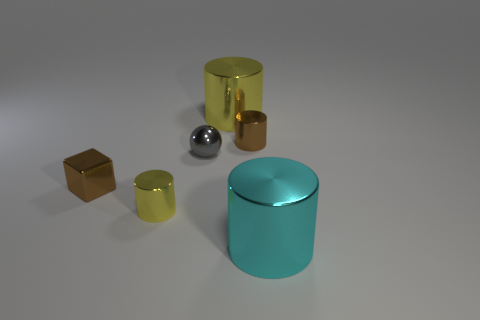Subtract all cyan cylinders. How many cylinders are left? 3 Subtract all red cylinders. Subtract all cyan cubes. How many cylinders are left? 4 Add 2 cyan cylinders. How many objects exist? 8 Subtract all cylinders. How many objects are left? 2 Subtract 0 cyan spheres. How many objects are left? 6 Subtract all small red metal things. Subtract all brown objects. How many objects are left? 4 Add 4 brown metal cylinders. How many brown metal cylinders are left? 5 Add 5 big red metal objects. How many big red metal objects exist? 5 